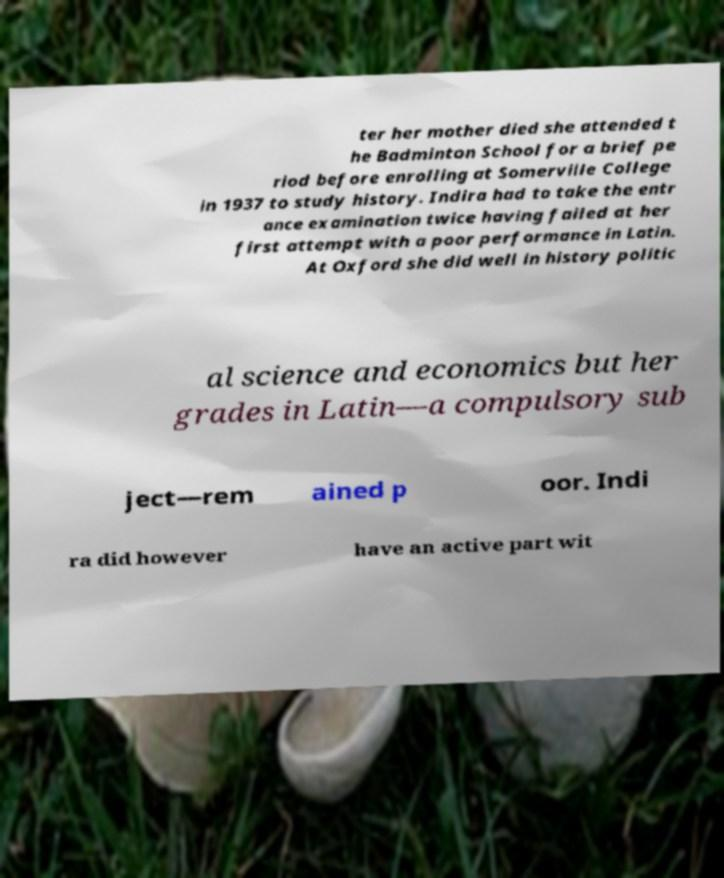Please identify and transcribe the text found in this image. ter her mother died she attended t he Badminton School for a brief pe riod before enrolling at Somerville College in 1937 to study history. Indira had to take the entr ance examination twice having failed at her first attempt with a poor performance in Latin. At Oxford she did well in history politic al science and economics but her grades in Latin—a compulsory sub ject—rem ained p oor. Indi ra did however have an active part wit 